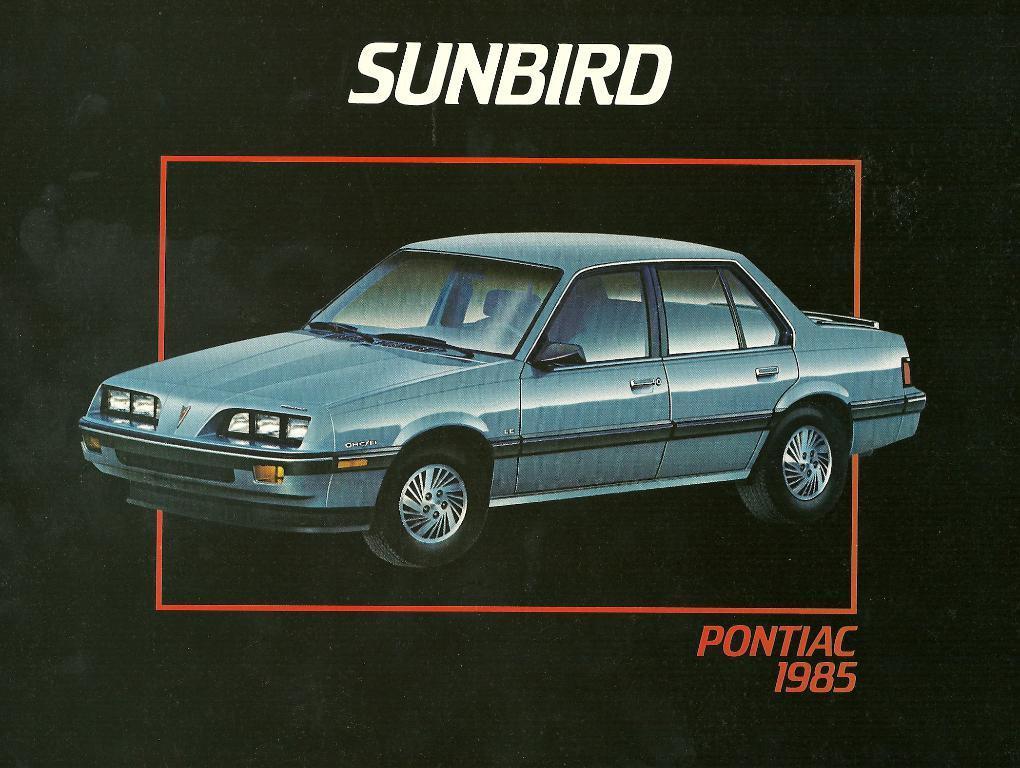Describe this image in one or two sentences. There is a image of a car in the middle of this image. There is some text written at the top of this image and bottom of this image as well. 